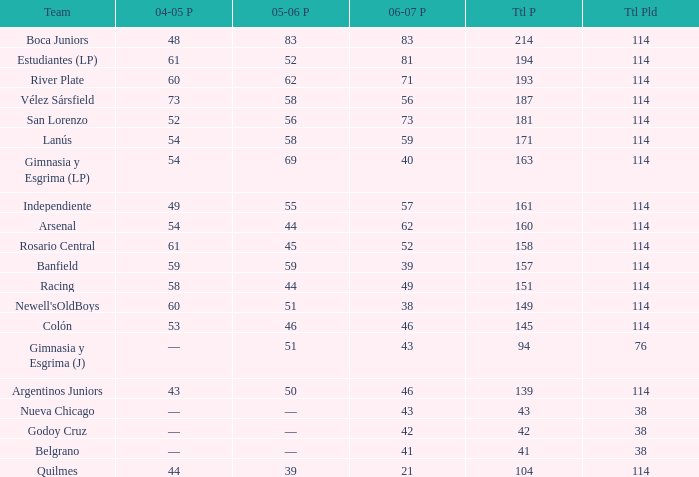What is the average total pld with 45 points in 2005-06, and more than 52 points in 2006-07? None. Can you parse all the data within this table? {'header': ['Team', '04-05 P', '05-06 P', '06-07 P', 'Ttl P', 'Ttl Pld'], 'rows': [['Boca Juniors', '48', '83', '83', '214', '114'], ['Estudiantes (LP)', '61', '52', '81', '194', '114'], ['River Plate', '60', '62', '71', '193', '114'], ['Vélez Sársfield', '73', '58', '56', '187', '114'], ['San Lorenzo', '52', '56', '73', '181', '114'], ['Lanús', '54', '58', '59', '171', '114'], ['Gimnasia y Esgrima (LP)', '54', '69', '40', '163', '114'], ['Independiente', '49', '55', '57', '161', '114'], ['Arsenal', '54', '44', '62', '160', '114'], ['Rosario Central', '61', '45', '52', '158', '114'], ['Banfield', '59', '59', '39', '157', '114'], ['Racing', '58', '44', '49', '151', '114'], ["Newell'sOldBoys", '60', '51', '38', '149', '114'], ['Colón', '53', '46', '46', '145', '114'], ['Gimnasia y Esgrima (J)', '—', '51', '43', '94', '76'], ['Argentinos Juniors', '43', '50', '46', '139', '114'], ['Nueva Chicago', '—', '—', '43', '43', '38'], ['Godoy Cruz', '—', '—', '42', '42', '38'], ['Belgrano', '—', '—', '41', '41', '38'], ['Quilmes', '44', '39', '21', '104', '114']]} 